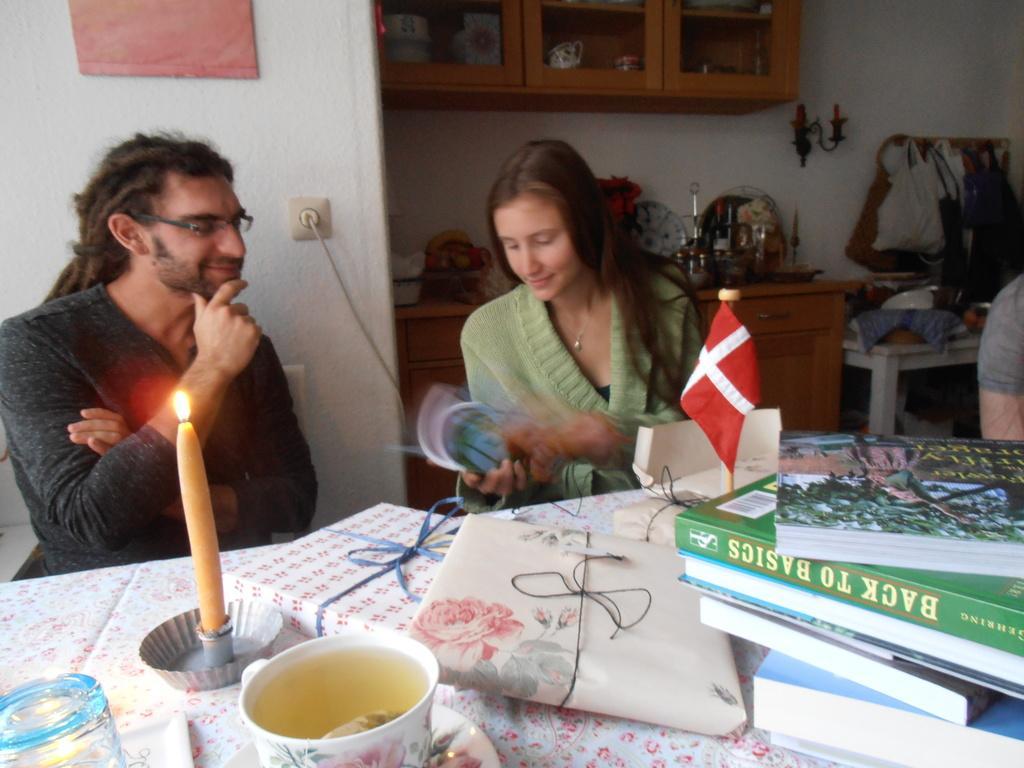Please provide a concise description of this image. In this picture a we can see a person is sitting on a chair, and beside a woman is sitting and holding a book in her hand, and in front there is a table a candle ,books and tea cup there are many objects, and at back side there is a table, and here is a wall an there are many objects on the table. 